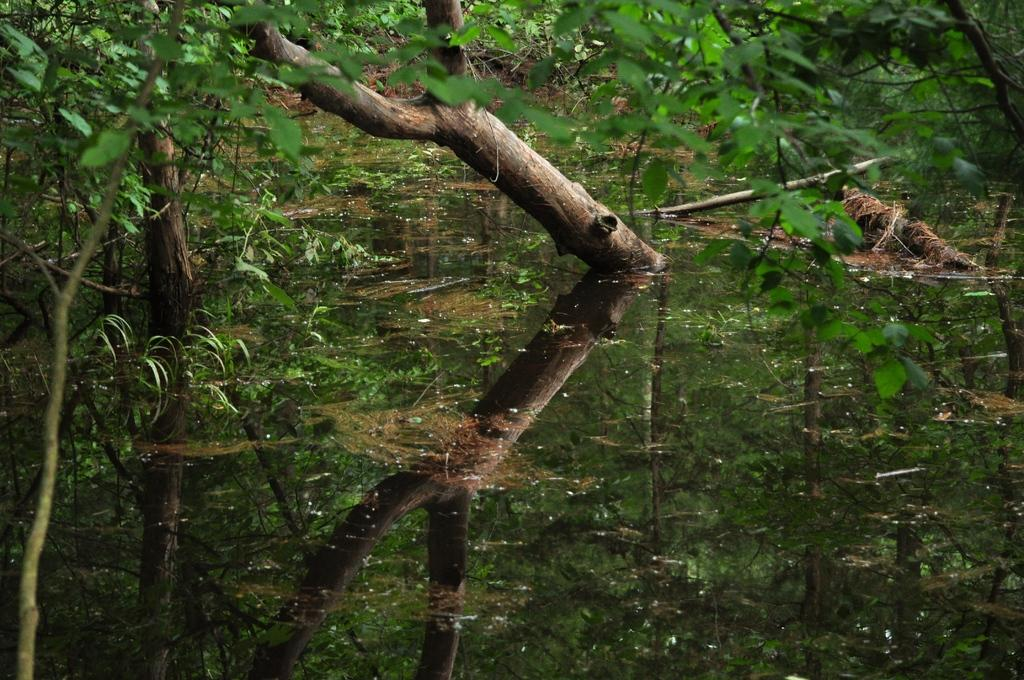What is visible in the image? There is water visible in the image. What can be seen in the background of the image? There are trees in the background of the image. What is the color of the trees? The trees are green in color. Where is the doctor standing in the image? There is no doctor present in the image. What type of bushes can be seen in the image? There are no bushes visible in the image; only trees are mentioned. 